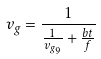Convert formula to latex. <formula><loc_0><loc_0><loc_500><loc_500>v _ { g } = \frac { 1 } { \frac { 1 } { v _ { g _ { 9 } } } + \frac { b t } { f } }</formula> 